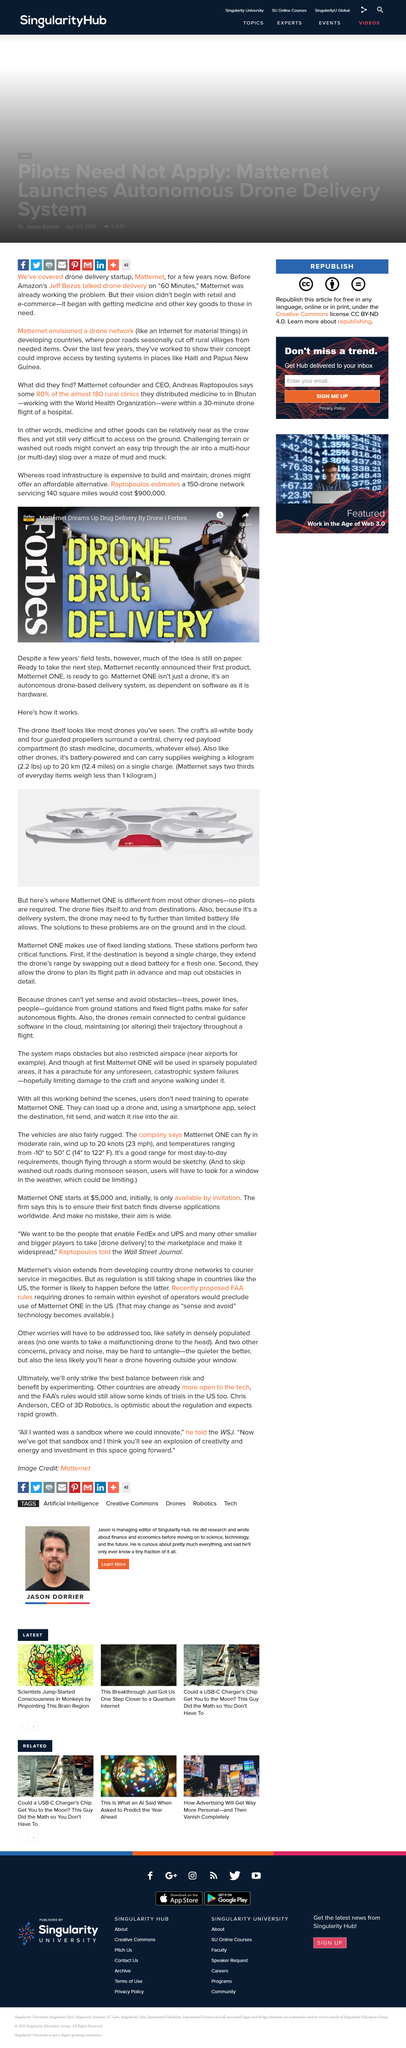Identify some key points in this picture. Safer autonomous flights for drones can be achieved by utilizing guidance from ground stations and adherence to fixed flight paths, as these measures ensure that the drone is unable to sense and avoid obstacles. Our drones are capable of carrying a 1 kilogram item for up to 20 kilometers on a single charge, making them ideal for a wide range of applications. Matternet ONE is connected to the cloud, and it allows users to access and control the drone from anywhere. Matternet ONE is a unique drone that stands out from others due to its innovative features, including the absence of human pilots. It is estimated that a 150 drone team would cost approximately $900,000 to cover an area of 140 square miles. 